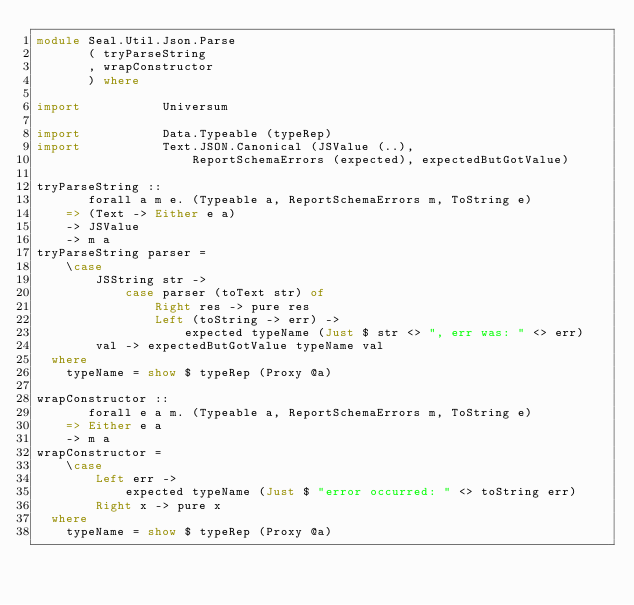Convert code to text. <code><loc_0><loc_0><loc_500><loc_500><_Haskell_>module Seal.Util.Json.Parse
       ( tryParseString
       , wrapConstructor
       ) where

import           Universum

import           Data.Typeable (typeRep)
import           Text.JSON.Canonical (JSValue (..),
                     ReportSchemaErrors (expected), expectedButGotValue)

tryParseString ::
       forall a m e. (Typeable a, ReportSchemaErrors m, ToString e)
    => (Text -> Either e a)
    -> JSValue
    -> m a
tryParseString parser =
    \case
        JSString str ->
            case parser (toText str) of
                Right res -> pure res
                Left (toString -> err) ->
                    expected typeName (Just $ str <> ", err was: " <> err)
        val -> expectedButGotValue typeName val
  where
    typeName = show $ typeRep (Proxy @a)

wrapConstructor ::
       forall e a m. (Typeable a, ReportSchemaErrors m, ToString e)
    => Either e a
    -> m a
wrapConstructor =
    \case
        Left err ->
            expected typeName (Just $ "error occurred: " <> toString err)
        Right x -> pure x
  where
    typeName = show $ typeRep (Proxy @a)
</code> 